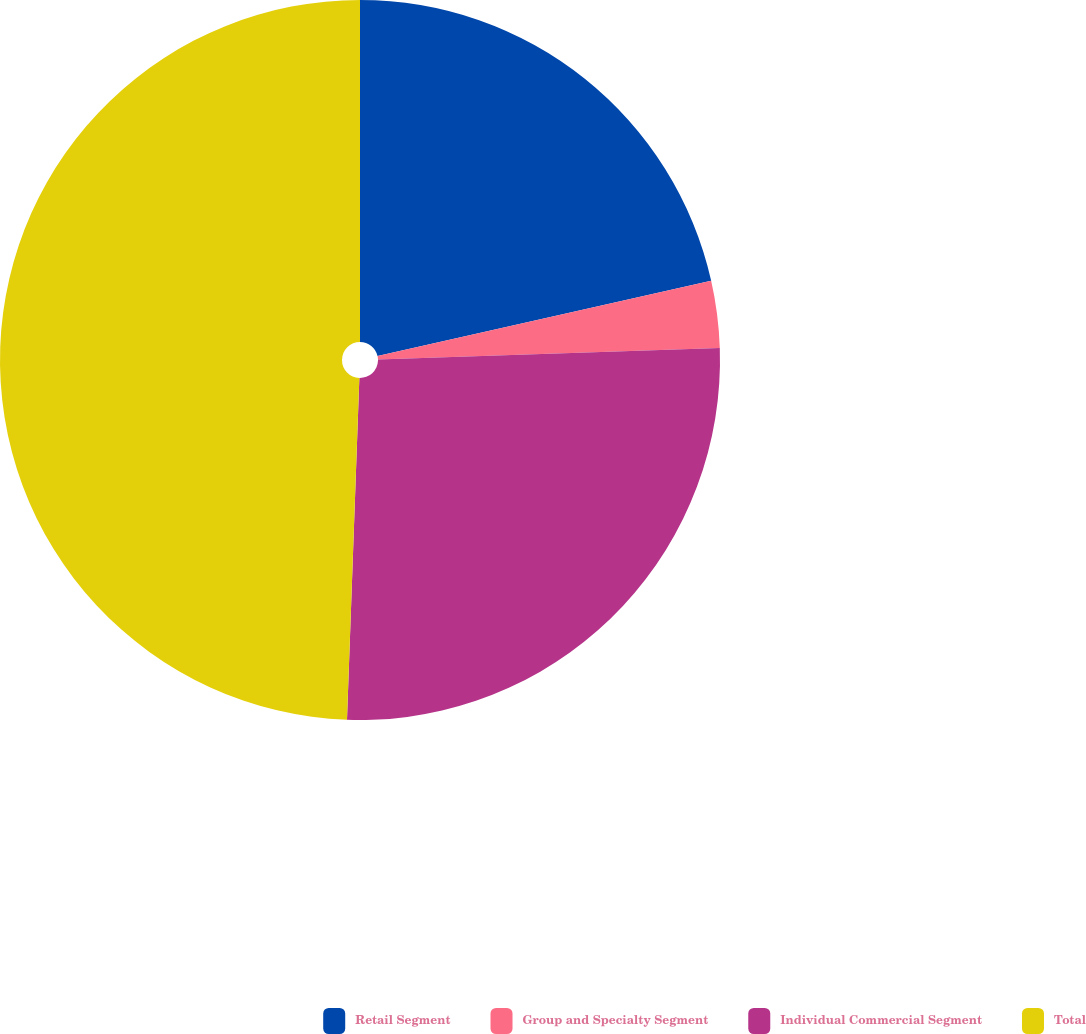Convert chart. <chart><loc_0><loc_0><loc_500><loc_500><pie_chart><fcel>Retail Segment<fcel>Group and Specialty Segment<fcel>Individual Commercial Segment<fcel>Total<nl><fcel>21.47%<fcel>3.0%<fcel>26.11%<fcel>49.43%<nl></chart> 